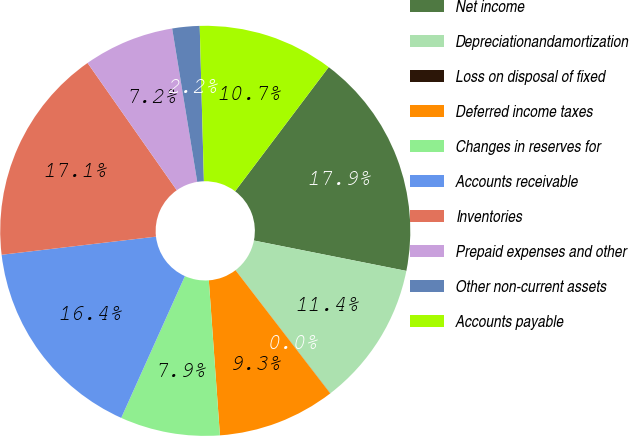Convert chart to OTSL. <chart><loc_0><loc_0><loc_500><loc_500><pie_chart><fcel>Net income<fcel>Depreciationandamortization<fcel>Loss on disposal of fixed<fcel>Deferred income taxes<fcel>Changes in reserves for<fcel>Accounts receivable<fcel>Inventories<fcel>Prepaid expenses and other<fcel>Other non-current assets<fcel>Accounts payable<nl><fcel>17.85%<fcel>11.43%<fcel>0.01%<fcel>9.29%<fcel>7.86%<fcel>16.42%<fcel>17.13%<fcel>7.15%<fcel>2.15%<fcel>10.71%<nl></chart> 